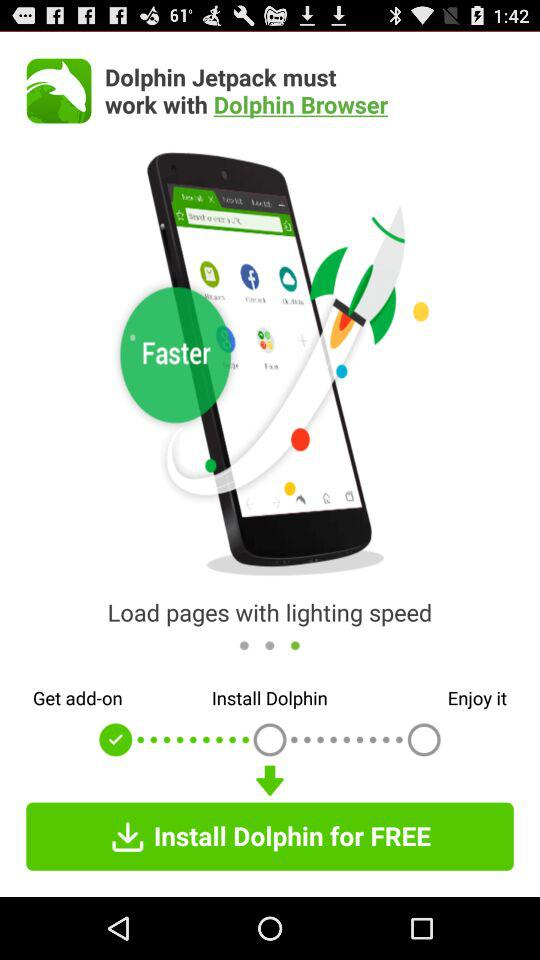What is the name of the application? The names of the applications are "Dolphin Jetpack" and "Dolphin Browser". 